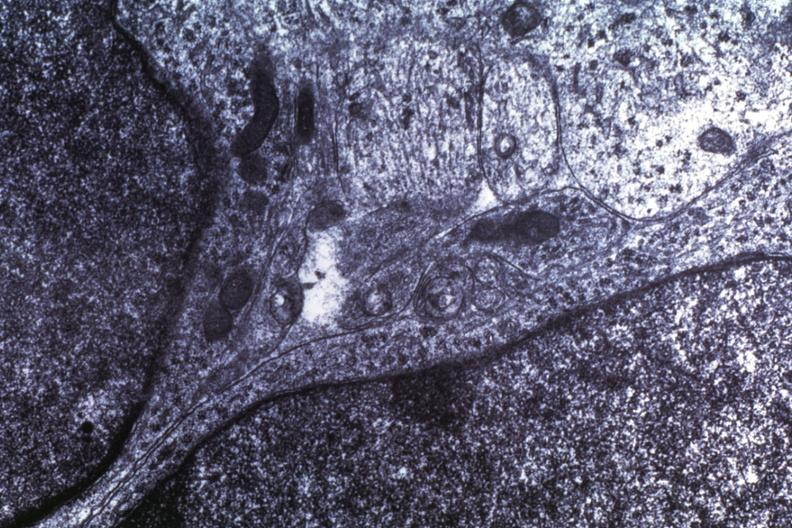what is present?
Answer the question using a single word or phrase. Medulloblastoma 